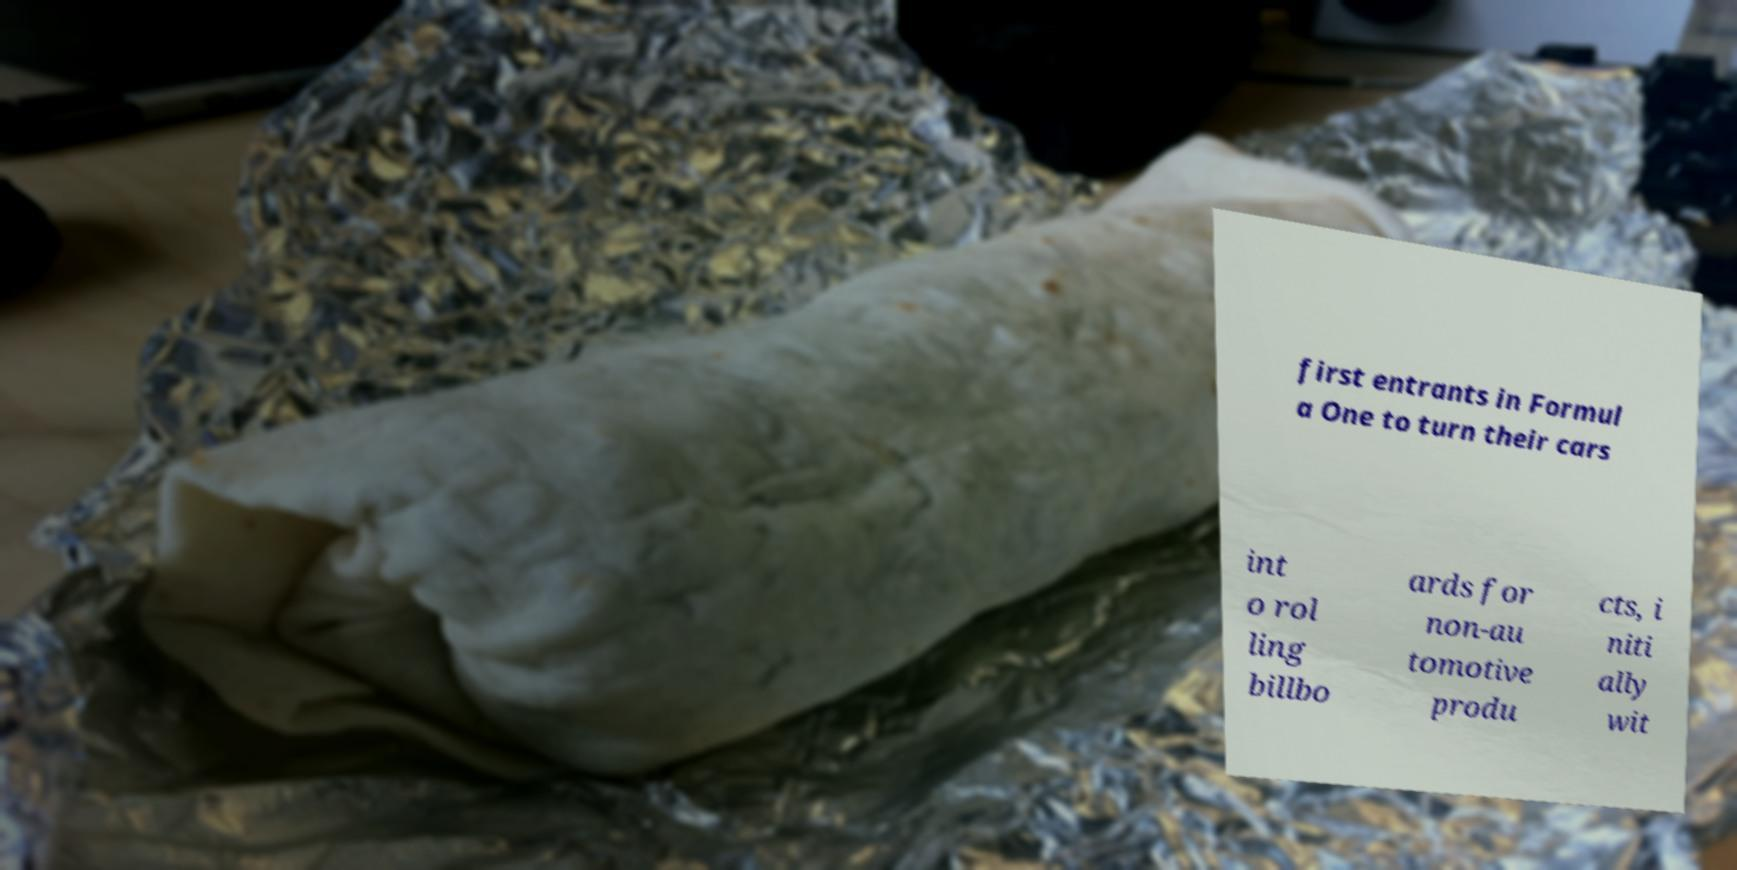There's text embedded in this image that I need extracted. Can you transcribe it verbatim? first entrants in Formul a One to turn their cars int o rol ling billbo ards for non-au tomotive produ cts, i niti ally wit 